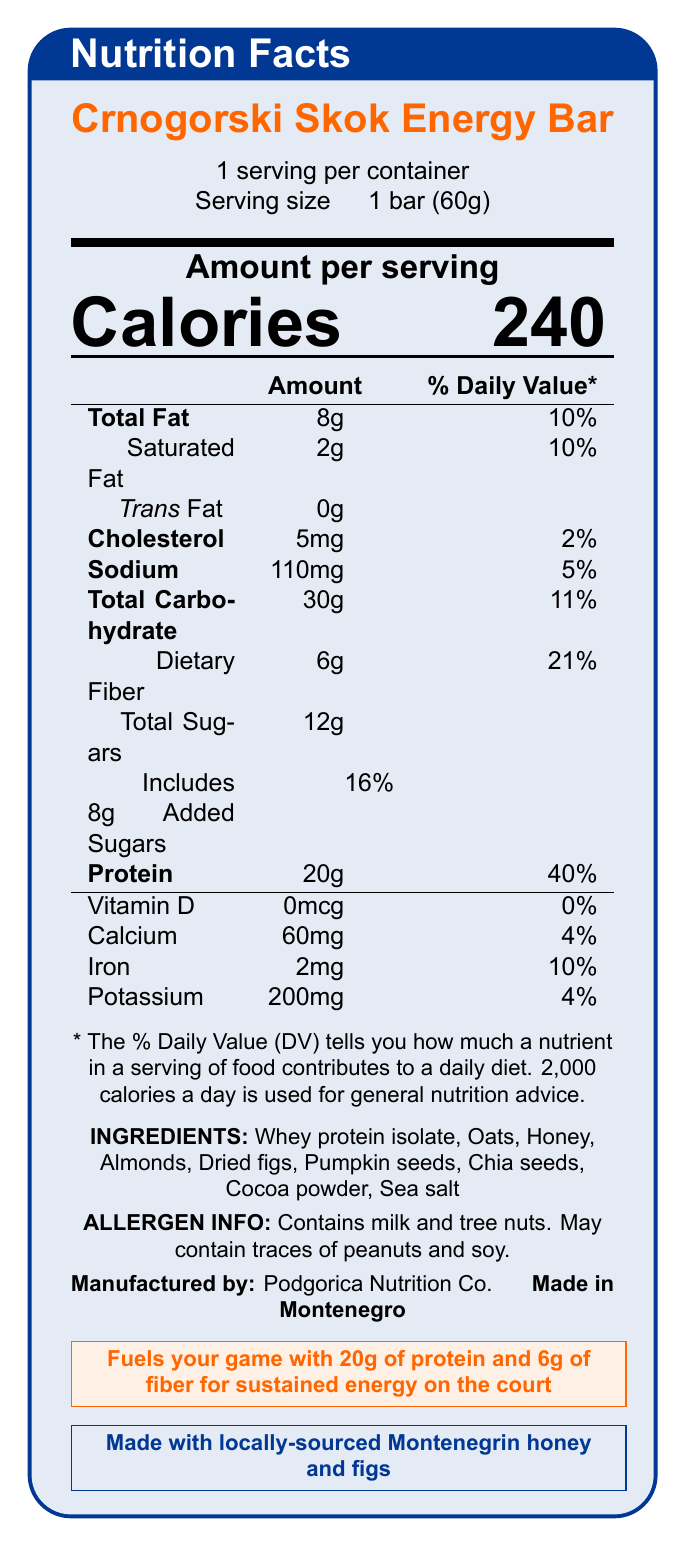what is the serving size of the Crnogorski Skok Energy Bar? The serving size is clearly mentioned as "1 bar (60g)" in the document.
Answer: 1 bar (60g) how many grams of protein are in one serving of the energy bar? The protein content per serving is listed as "20g" in the document.
Answer: 20g what is the daily value percentage of dietary fiber in one serving? The percentage of the daily value for dietary fiber per serving is noted as "21%" in the document.
Answer: 21% what is the total carbohydrate amount in one serving? The document specifies that the total carbohydrate content is "30g" per serving.
Answer: 30g what are the main ingredients of this energy bar? The ingredients list includes these items as shown in the document.
Answer: Whey protein isolate, Oats, Honey, Almonds, Dried figs, Pumpkin seeds, Chia seeds, Cocoa powder, Sea salt what is the % daily value of saturated fat in one serving? A. 5% B. 10% C. 15% D. 20% The document lists the % daily value of saturated fat as "10%".
Answer: B. 10% how many grams of total sugars are in the energy bar? A. 6g B. 8g C. 12g D. 16g The document states that the total sugars amount to "12g".
Answer: C. 12g does the energy bar contain any calcium? The document indicates that the energy bar contains "60mg" of calcium, which is "4%" of the daily value.
Answer: Yes is this product made with locally-sourced ingredients? The document mentions that the product is "made with locally-sourced Montenegrin honey and figs".
Answer: Yes what is the origin of the Crnogorski Skok Energy Bar? The document clearly states that the energy bar is "Made in Montenegro".
Answer: Made in Montenegro how many calories are in one serving of the energy bar? The calorie content per serving is explicitly mentioned as "240" calories in the document.
Answer: 240 does the label suggest any health benefits related to sports performance? The label claims that the energy bar "Fuels your game with 20g of protein and 6g of fiber for sustained energy on the court".
Answer: Yes what allergens does the energy bar contain? The document specifies that the energy bar contains milk and tree nuts.
Answer: Milk and tree nuts does the energy bar contain any trans fat? The document lists "0g" trans fat under the nutrition facts.
Answer: No how would you describe the main idea of the document? The document primarily focuses on presenting the nutritional composition and health benefits of the Crnogorski Skok Energy Bar, emphasizing its suitability for basketball players and its use of local Montenegrin ingredients.
Answer: The nutrition facts label provides detailed information about the Crnogorski Skok Energy Bar, highlighting its high protein and fiber content, local ingredients, and fitness benefits for basketball players. It also includes information on serving size, calories, macronutrient breakdown, vitamins and minerals, ingredient list, allergens, and manufacturing details. what is the sugar content from added sugars in the energy bar? The document shows that the energy bar includes "8g" of added sugars, which makes up "16%" of the daily value.
Answer: 8g what company manufactures this energy bar? The document states that the energy bar is manufactured by "Podgorica Nutrition Co."
Answer: Podgorica Nutrition Co. how much iron does one serving of the energy bar provide? The iron content per serving is stated as "2mg" in the document.
Answer: 2mg how many scoops of protein powder are used in the bar? The document does not provide any information regarding the number of scoops of protein powder used in the bar.
Answer: Not enough information 